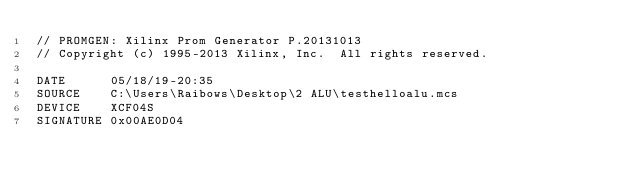<code> <loc_0><loc_0><loc_500><loc_500><_SML_>// PROMGEN: Xilinx Prom Generator P.20131013
// Copyright (c) 1995-2013 Xilinx, Inc.  All rights reserved.

DATE      05/18/19-20:35
SOURCE    C:\Users\Raibows\Desktop\2 ALU\testhelloalu.mcs
DEVICE    XCF04S
SIGNATURE 0x00AE0D04
</code> 